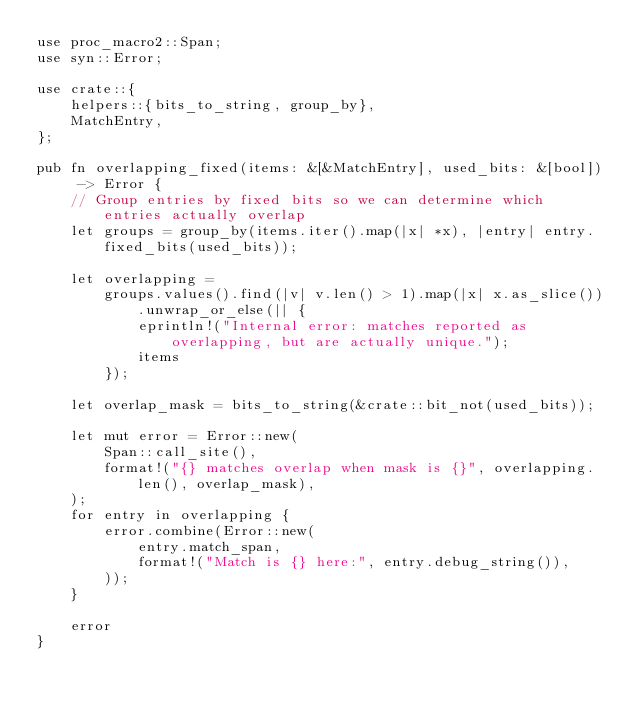<code> <loc_0><loc_0><loc_500><loc_500><_Rust_>use proc_macro2::Span;
use syn::Error;

use crate::{
    helpers::{bits_to_string, group_by},
    MatchEntry,
};

pub fn overlapping_fixed(items: &[&MatchEntry], used_bits: &[bool]) -> Error {
    // Group entries by fixed bits so we can determine which entries actually overlap
    let groups = group_by(items.iter().map(|x| *x), |entry| entry.fixed_bits(used_bits));

    let overlapping =
        groups.values().find(|v| v.len() > 1).map(|x| x.as_slice()).unwrap_or_else(|| {
            eprintln!("Internal error: matches reported as overlapping, but are actually unique.");
            items
        });

    let overlap_mask = bits_to_string(&crate::bit_not(used_bits));

    let mut error = Error::new(
        Span::call_site(),
        format!("{} matches overlap when mask is {}", overlapping.len(), overlap_mask),
    );
    for entry in overlapping {
        error.combine(Error::new(
            entry.match_span,
            format!("Match is {} here:", entry.debug_string()),
        ));
    }

    error
}
</code> 